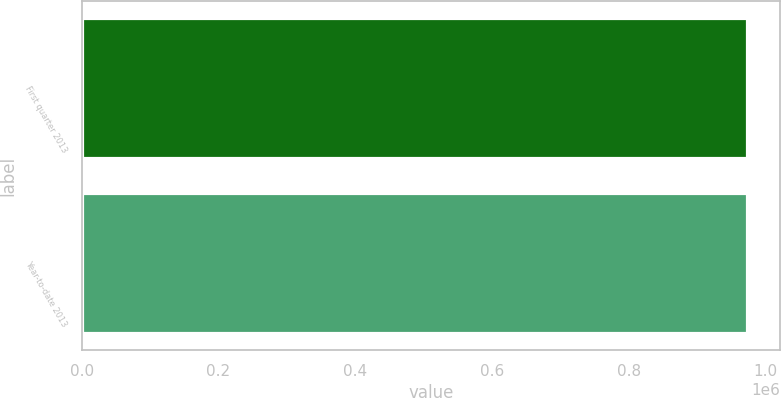<chart> <loc_0><loc_0><loc_500><loc_500><bar_chart><fcel>First quarter 2013<fcel>Year-to-date 2013<nl><fcel>972292<fcel>972292<nl></chart> 